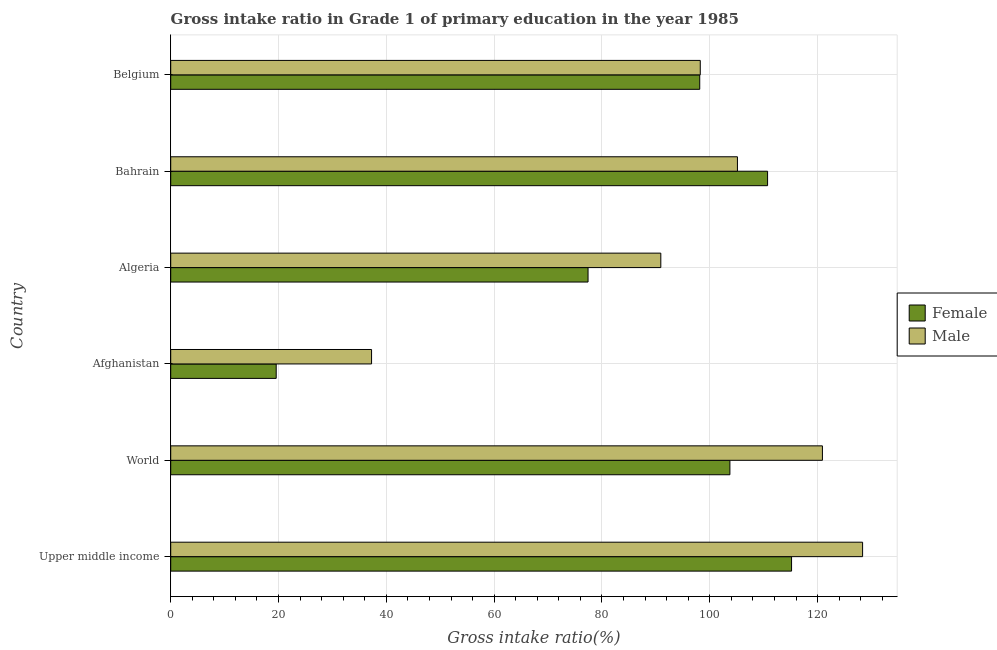How many different coloured bars are there?
Give a very brief answer. 2. How many groups of bars are there?
Your answer should be compact. 6. Are the number of bars per tick equal to the number of legend labels?
Ensure brevity in your answer.  Yes. Are the number of bars on each tick of the Y-axis equal?
Provide a short and direct response. Yes. How many bars are there on the 6th tick from the top?
Offer a very short reply. 2. How many bars are there on the 3rd tick from the bottom?
Give a very brief answer. 2. What is the label of the 1st group of bars from the top?
Ensure brevity in your answer.  Belgium. What is the gross intake ratio(male) in World?
Offer a terse response. 120.89. Across all countries, what is the maximum gross intake ratio(male)?
Ensure brevity in your answer.  128.34. Across all countries, what is the minimum gross intake ratio(male)?
Keep it short and to the point. 37.26. In which country was the gross intake ratio(male) maximum?
Give a very brief answer. Upper middle income. In which country was the gross intake ratio(female) minimum?
Ensure brevity in your answer.  Afghanistan. What is the total gross intake ratio(male) in the graph?
Ensure brevity in your answer.  580.76. What is the difference between the gross intake ratio(male) in Belgium and that in World?
Offer a very short reply. -22.66. What is the difference between the gross intake ratio(female) in Upper middle income and the gross intake ratio(male) in Afghanistan?
Offer a very short reply. 77.91. What is the average gross intake ratio(male) per country?
Your response must be concise. 96.79. What is the difference between the gross intake ratio(male) and gross intake ratio(female) in Upper middle income?
Your response must be concise. 13.18. In how many countries, is the gross intake ratio(male) greater than 84 %?
Make the answer very short. 5. What is the ratio of the gross intake ratio(female) in Algeria to that in Bahrain?
Your response must be concise. 0.7. What is the difference between the highest and the second highest gross intake ratio(male)?
Offer a terse response. 7.45. What is the difference between the highest and the lowest gross intake ratio(male)?
Your response must be concise. 91.08. In how many countries, is the gross intake ratio(male) greater than the average gross intake ratio(male) taken over all countries?
Make the answer very short. 4. Is the sum of the gross intake ratio(female) in Belgium and Upper middle income greater than the maximum gross intake ratio(male) across all countries?
Keep it short and to the point. Yes. What does the 1st bar from the top in Afghanistan represents?
Your answer should be very brief. Male. How many bars are there?
Keep it short and to the point. 12. Are all the bars in the graph horizontal?
Your answer should be very brief. Yes. How many countries are there in the graph?
Provide a short and direct response. 6. Does the graph contain grids?
Make the answer very short. Yes. How many legend labels are there?
Offer a terse response. 2. What is the title of the graph?
Provide a short and direct response. Gross intake ratio in Grade 1 of primary education in the year 1985. What is the label or title of the X-axis?
Provide a succinct answer. Gross intake ratio(%). What is the label or title of the Y-axis?
Provide a succinct answer. Country. What is the Gross intake ratio(%) of Female in Upper middle income?
Make the answer very short. 115.16. What is the Gross intake ratio(%) of Male in Upper middle income?
Provide a succinct answer. 128.34. What is the Gross intake ratio(%) of Female in World?
Your answer should be very brief. 103.73. What is the Gross intake ratio(%) in Male in World?
Your answer should be compact. 120.89. What is the Gross intake ratio(%) of Female in Afghanistan?
Provide a succinct answer. 19.57. What is the Gross intake ratio(%) in Male in Afghanistan?
Make the answer very short. 37.26. What is the Gross intake ratio(%) in Female in Algeria?
Make the answer very short. 77.41. What is the Gross intake ratio(%) in Male in Algeria?
Offer a very short reply. 90.91. What is the Gross intake ratio(%) in Female in Bahrain?
Make the answer very short. 110.72. What is the Gross intake ratio(%) in Male in Bahrain?
Keep it short and to the point. 105.12. What is the Gross intake ratio(%) in Female in Belgium?
Make the answer very short. 98.13. What is the Gross intake ratio(%) in Male in Belgium?
Ensure brevity in your answer.  98.23. Across all countries, what is the maximum Gross intake ratio(%) of Female?
Ensure brevity in your answer.  115.16. Across all countries, what is the maximum Gross intake ratio(%) of Male?
Your answer should be compact. 128.34. Across all countries, what is the minimum Gross intake ratio(%) of Female?
Offer a terse response. 19.57. Across all countries, what is the minimum Gross intake ratio(%) in Male?
Your response must be concise. 37.26. What is the total Gross intake ratio(%) in Female in the graph?
Your response must be concise. 524.72. What is the total Gross intake ratio(%) of Male in the graph?
Ensure brevity in your answer.  580.76. What is the difference between the Gross intake ratio(%) of Female in Upper middle income and that in World?
Your answer should be very brief. 11.44. What is the difference between the Gross intake ratio(%) in Male in Upper middle income and that in World?
Give a very brief answer. 7.45. What is the difference between the Gross intake ratio(%) of Female in Upper middle income and that in Afghanistan?
Offer a terse response. 95.6. What is the difference between the Gross intake ratio(%) in Male in Upper middle income and that in Afghanistan?
Make the answer very short. 91.08. What is the difference between the Gross intake ratio(%) in Female in Upper middle income and that in Algeria?
Your answer should be very brief. 37.75. What is the difference between the Gross intake ratio(%) of Male in Upper middle income and that in Algeria?
Give a very brief answer. 37.43. What is the difference between the Gross intake ratio(%) of Female in Upper middle income and that in Bahrain?
Your answer should be very brief. 4.45. What is the difference between the Gross intake ratio(%) of Male in Upper middle income and that in Bahrain?
Your response must be concise. 23.22. What is the difference between the Gross intake ratio(%) in Female in Upper middle income and that in Belgium?
Your answer should be compact. 17.03. What is the difference between the Gross intake ratio(%) in Male in Upper middle income and that in Belgium?
Make the answer very short. 30.11. What is the difference between the Gross intake ratio(%) of Female in World and that in Afghanistan?
Your answer should be very brief. 84.16. What is the difference between the Gross intake ratio(%) in Male in World and that in Afghanistan?
Ensure brevity in your answer.  83.63. What is the difference between the Gross intake ratio(%) in Female in World and that in Algeria?
Give a very brief answer. 26.31. What is the difference between the Gross intake ratio(%) in Male in World and that in Algeria?
Provide a short and direct response. 29.98. What is the difference between the Gross intake ratio(%) of Female in World and that in Bahrain?
Offer a very short reply. -6.99. What is the difference between the Gross intake ratio(%) in Male in World and that in Bahrain?
Offer a very short reply. 15.76. What is the difference between the Gross intake ratio(%) of Female in World and that in Belgium?
Your response must be concise. 5.6. What is the difference between the Gross intake ratio(%) of Male in World and that in Belgium?
Provide a short and direct response. 22.66. What is the difference between the Gross intake ratio(%) in Female in Afghanistan and that in Algeria?
Provide a short and direct response. -57.85. What is the difference between the Gross intake ratio(%) in Male in Afghanistan and that in Algeria?
Keep it short and to the point. -53.66. What is the difference between the Gross intake ratio(%) of Female in Afghanistan and that in Bahrain?
Offer a terse response. -91.15. What is the difference between the Gross intake ratio(%) in Male in Afghanistan and that in Bahrain?
Make the answer very short. -67.87. What is the difference between the Gross intake ratio(%) of Female in Afghanistan and that in Belgium?
Offer a very short reply. -78.56. What is the difference between the Gross intake ratio(%) of Male in Afghanistan and that in Belgium?
Make the answer very short. -60.97. What is the difference between the Gross intake ratio(%) in Female in Algeria and that in Bahrain?
Your answer should be compact. -33.3. What is the difference between the Gross intake ratio(%) in Male in Algeria and that in Bahrain?
Give a very brief answer. -14.21. What is the difference between the Gross intake ratio(%) of Female in Algeria and that in Belgium?
Provide a succinct answer. -20.72. What is the difference between the Gross intake ratio(%) of Male in Algeria and that in Belgium?
Give a very brief answer. -7.32. What is the difference between the Gross intake ratio(%) in Female in Bahrain and that in Belgium?
Provide a short and direct response. 12.59. What is the difference between the Gross intake ratio(%) in Male in Bahrain and that in Belgium?
Provide a succinct answer. 6.89. What is the difference between the Gross intake ratio(%) in Female in Upper middle income and the Gross intake ratio(%) in Male in World?
Provide a short and direct response. -5.72. What is the difference between the Gross intake ratio(%) in Female in Upper middle income and the Gross intake ratio(%) in Male in Afghanistan?
Offer a very short reply. 77.91. What is the difference between the Gross intake ratio(%) in Female in Upper middle income and the Gross intake ratio(%) in Male in Algeria?
Provide a succinct answer. 24.25. What is the difference between the Gross intake ratio(%) in Female in Upper middle income and the Gross intake ratio(%) in Male in Bahrain?
Your answer should be very brief. 10.04. What is the difference between the Gross intake ratio(%) in Female in Upper middle income and the Gross intake ratio(%) in Male in Belgium?
Give a very brief answer. 16.93. What is the difference between the Gross intake ratio(%) of Female in World and the Gross intake ratio(%) of Male in Afghanistan?
Provide a short and direct response. 66.47. What is the difference between the Gross intake ratio(%) in Female in World and the Gross intake ratio(%) in Male in Algeria?
Offer a very short reply. 12.81. What is the difference between the Gross intake ratio(%) of Female in World and the Gross intake ratio(%) of Male in Bahrain?
Your response must be concise. -1.4. What is the difference between the Gross intake ratio(%) in Female in World and the Gross intake ratio(%) in Male in Belgium?
Your answer should be very brief. 5.5. What is the difference between the Gross intake ratio(%) of Female in Afghanistan and the Gross intake ratio(%) of Male in Algeria?
Your answer should be compact. -71.35. What is the difference between the Gross intake ratio(%) of Female in Afghanistan and the Gross intake ratio(%) of Male in Bahrain?
Offer a terse response. -85.56. What is the difference between the Gross intake ratio(%) in Female in Afghanistan and the Gross intake ratio(%) in Male in Belgium?
Your response must be concise. -78.66. What is the difference between the Gross intake ratio(%) in Female in Algeria and the Gross intake ratio(%) in Male in Bahrain?
Your answer should be very brief. -27.71. What is the difference between the Gross intake ratio(%) in Female in Algeria and the Gross intake ratio(%) in Male in Belgium?
Make the answer very short. -20.82. What is the difference between the Gross intake ratio(%) in Female in Bahrain and the Gross intake ratio(%) in Male in Belgium?
Ensure brevity in your answer.  12.49. What is the average Gross intake ratio(%) in Female per country?
Provide a short and direct response. 87.45. What is the average Gross intake ratio(%) in Male per country?
Provide a short and direct response. 96.79. What is the difference between the Gross intake ratio(%) in Female and Gross intake ratio(%) in Male in Upper middle income?
Ensure brevity in your answer.  -13.18. What is the difference between the Gross intake ratio(%) in Female and Gross intake ratio(%) in Male in World?
Offer a terse response. -17.16. What is the difference between the Gross intake ratio(%) of Female and Gross intake ratio(%) of Male in Afghanistan?
Keep it short and to the point. -17.69. What is the difference between the Gross intake ratio(%) of Female and Gross intake ratio(%) of Male in Algeria?
Keep it short and to the point. -13.5. What is the difference between the Gross intake ratio(%) in Female and Gross intake ratio(%) in Male in Bahrain?
Your response must be concise. 5.59. What is the difference between the Gross intake ratio(%) in Female and Gross intake ratio(%) in Male in Belgium?
Provide a short and direct response. -0.1. What is the ratio of the Gross intake ratio(%) in Female in Upper middle income to that in World?
Offer a terse response. 1.11. What is the ratio of the Gross intake ratio(%) in Male in Upper middle income to that in World?
Make the answer very short. 1.06. What is the ratio of the Gross intake ratio(%) of Female in Upper middle income to that in Afghanistan?
Make the answer very short. 5.89. What is the ratio of the Gross intake ratio(%) of Male in Upper middle income to that in Afghanistan?
Provide a succinct answer. 3.44. What is the ratio of the Gross intake ratio(%) in Female in Upper middle income to that in Algeria?
Provide a succinct answer. 1.49. What is the ratio of the Gross intake ratio(%) of Male in Upper middle income to that in Algeria?
Provide a succinct answer. 1.41. What is the ratio of the Gross intake ratio(%) of Female in Upper middle income to that in Bahrain?
Your answer should be very brief. 1.04. What is the ratio of the Gross intake ratio(%) in Male in Upper middle income to that in Bahrain?
Offer a very short reply. 1.22. What is the ratio of the Gross intake ratio(%) of Female in Upper middle income to that in Belgium?
Offer a terse response. 1.17. What is the ratio of the Gross intake ratio(%) of Male in Upper middle income to that in Belgium?
Ensure brevity in your answer.  1.31. What is the ratio of the Gross intake ratio(%) of Female in World to that in Afghanistan?
Your answer should be compact. 5.3. What is the ratio of the Gross intake ratio(%) of Male in World to that in Afghanistan?
Your answer should be compact. 3.24. What is the ratio of the Gross intake ratio(%) in Female in World to that in Algeria?
Provide a short and direct response. 1.34. What is the ratio of the Gross intake ratio(%) in Male in World to that in Algeria?
Ensure brevity in your answer.  1.33. What is the ratio of the Gross intake ratio(%) of Female in World to that in Bahrain?
Provide a succinct answer. 0.94. What is the ratio of the Gross intake ratio(%) of Male in World to that in Bahrain?
Offer a very short reply. 1.15. What is the ratio of the Gross intake ratio(%) of Female in World to that in Belgium?
Keep it short and to the point. 1.06. What is the ratio of the Gross intake ratio(%) in Male in World to that in Belgium?
Provide a short and direct response. 1.23. What is the ratio of the Gross intake ratio(%) in Female in Afghanistan to that in Algeria?
Ensure brevity in your answer.  0.25. What is the ratio of the Gross intake ratio(%) in Male in Afghanistan to that in Algeria?
Your response must be concise. 0.41. What is the ratio of the Gross intake ratio(%) of Female in Afghanistan to that in Bahrain?
Offer a terse response. 0.18. What is the ratio of the Gross intake ratio(%) of Male in Afghanistan to that in Bahrain?
Your answer should be very brief. 0.35. What is the ratio of the Gross intake ratio(%) in Female in Afghanistan to that in Belgium?
Provide a short and direct response. 0.2. What is the ratio of the Gross intake ratio(%) of Male in Afghanistan to that in Belgium?
Offer a very short reply. 0.38. What is the ratio of the Gross intake ratio(%) in Female in Algeria to that in Bahrain?
Give a very brief answer. 0.7. What is the ratio of the Gross intake ratio(%) in Male in Algeria to that in Bahrain?
Your response must be concise. 0.86. What is the ratio of the Gross intake ratio(%) of Female in Algeria to that in Belgium?
Keep it short and to the point. 0.79. What is the ratio of the Gross intake ratio(%) in Male in Algeria to that in Belgium?
Provide a short and direct response. 0.93. What is the ratio of the Gross intake ratio(%) in Female in Bahrain to that in Belgium?
Ensure brevity in your answer.  1.13. What is the ratio of the Gross intake ratio(%) in Male in Bahrain to that in Belgium?
Ensure brevity in your answer.  1.07. What is the difference between the highest and the second highest Gross intake ratio(%) in Female?
Ensure brevity in your answer.  4.45. What is the difference between the highest and the second highest Gross intake ratio(%) in Male?
Provide a short and direct response. 7.45. What is the difference between the highest and the lowest Gross intake ratio(%) in Female?
Ensure brevity in your answer.  95.6. What is the difference between the highest and the lowest Gross intake ratio(%) in Male?
Keep it short and to the point. 91.08. 